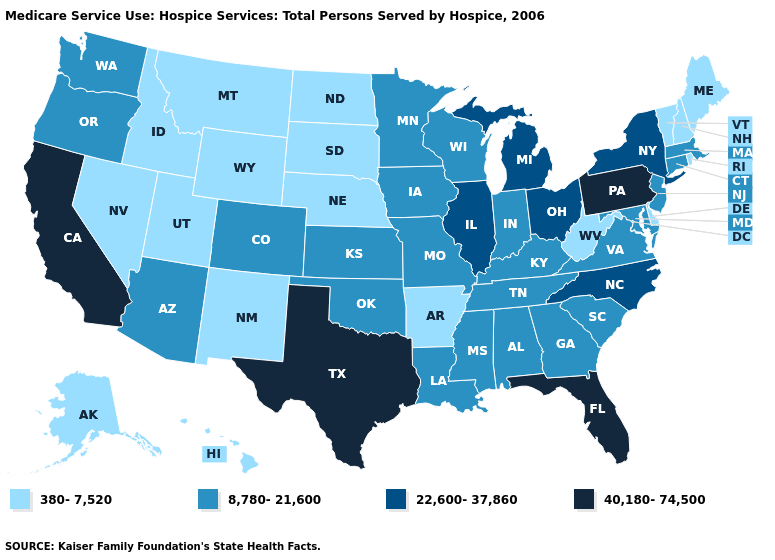Name the states that have a value in the range 22,600-37,860?
Keep it brief. Illinois, Michigan, New York, North Carolina, Ohio. How many symbols are there in the legend?
Concise answer only. 4. Does Idaho have a lower value than Florida?
Short answer required. Yes. What is the value of Hawaii?
Answer briefly. 380-7,520. What is the value of Georgia?
Answer briefly. 8,780-21,600. What is the lowest value in the Northeast?
Short answer required. 380-7,520. Does Georgia have the lowest value in the South?
Quick response, please. No. Name the states that have a value in the range 380-7,520?
Write a very short answer. Alaska, Arkansas, Delaware, Hawaii, Idaho, Maine, Montana, Nebraska, Nevada, New Hampshire, New Mexico, North Dakota, Rhode Island, South Dakota, Utah, Vermont, West Virginia, Wyoming. Which states have the highest value in the USA?
Keep it brief. California, Florida, Pennsylvania, Texas. What is the value of Arkansas?
Quick response, please. 380-7,520. Does the map have missing data?
Keep it brief. No. What is the highest value in the South ?
Be succinct. 40,180-74,500. What is the value of Georgia?
Answer briefly. 8,780-21,600. What is the value of Idaho?
Short answer required. 380-7,520. Does Missouri have a lower value than South Dakota?
Be succinct. No. 